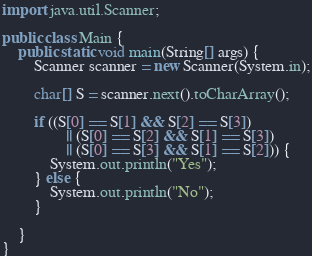Convert code to text. <code><loc_0><loc_0><loc_500><loc_500><_Java_>
import java.util.Scanner;

public class Main {
    public static void main(String[] args) {
        Scanner scanner = new Scanner(System.in);

        char[] S = scanner.next().toCharArray();

        if ((S[0] == S[1] && S[2] == S[3])
                || (S[0] == S[2] && S[1] == S[3])
                || (S[0] == S[3] && S[1] == S[2])) {
            System.out.println("Yes");
        } else {
            System.out.println("No");
        }

    }
}
</code> 